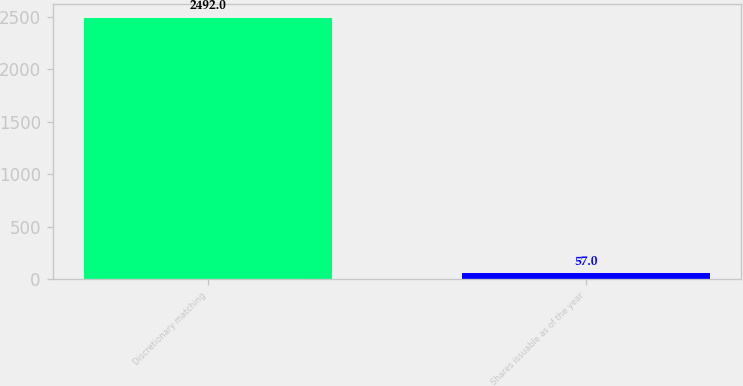<chart> <loc_0><loc_0><loc_500><loc_500><bar_chart><fcel>Discretionary matching<fcel>Shares issuable as of the year<nl><fcel>2492<fcel>57<nl></chart> 